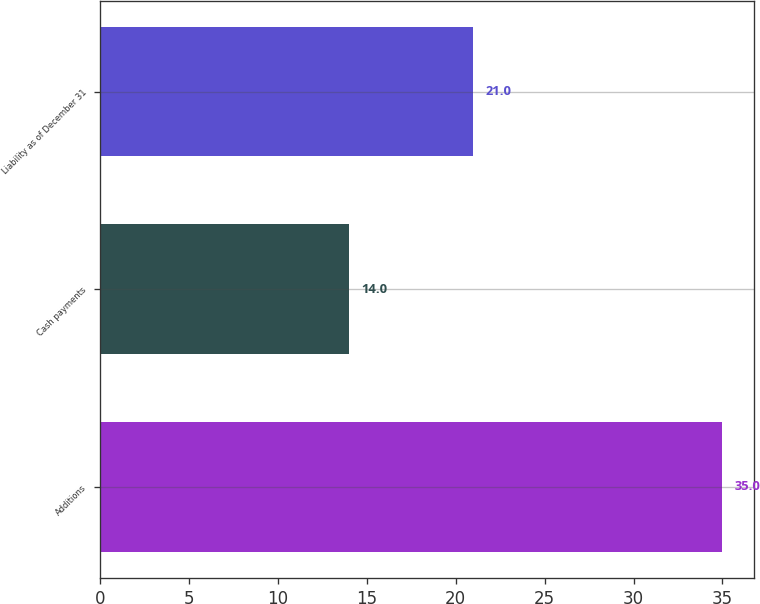Convert chart. <chart><loc_0><loc_0><loc_500><loc_500><bar_chart><fcel>Additions<fcel>Cash payments<fcel>Liability as of December 31<nl><fcel>35<fcel>14<fcel>21<nl></chart> 